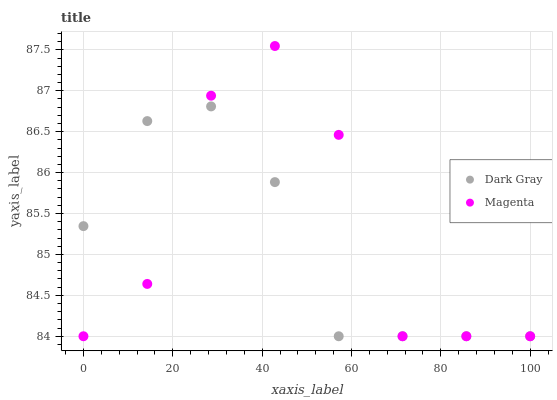Does Dark Gray have the minimum area under the curve?
Answer yes or no. Yes. Does Magenta have the maximum area under the curve?
Answer yes or no. Yes. Does Magenta have the minimum area under the curve?
Answer yes or no. No. Is Dark Gray the smoothest?
Answer yes or no. Yes. Is Magenta the roughest?
Answer yes or no. Yes. Is Magenta the smoothest?
Answer yes or no. No. Does Dark Gray have the lowest value?
Answer yes or no. Yes. Does Magenta have the highest value?
Answer yes or no. Yes. Does Magenta intersect Dark Gray?
Answer yes or no. Yes. Is Magenta less than Dark Gray?
Answer yes or no. No. Is Magenta greater than Dark Gray?
Answer yes or no. No. 